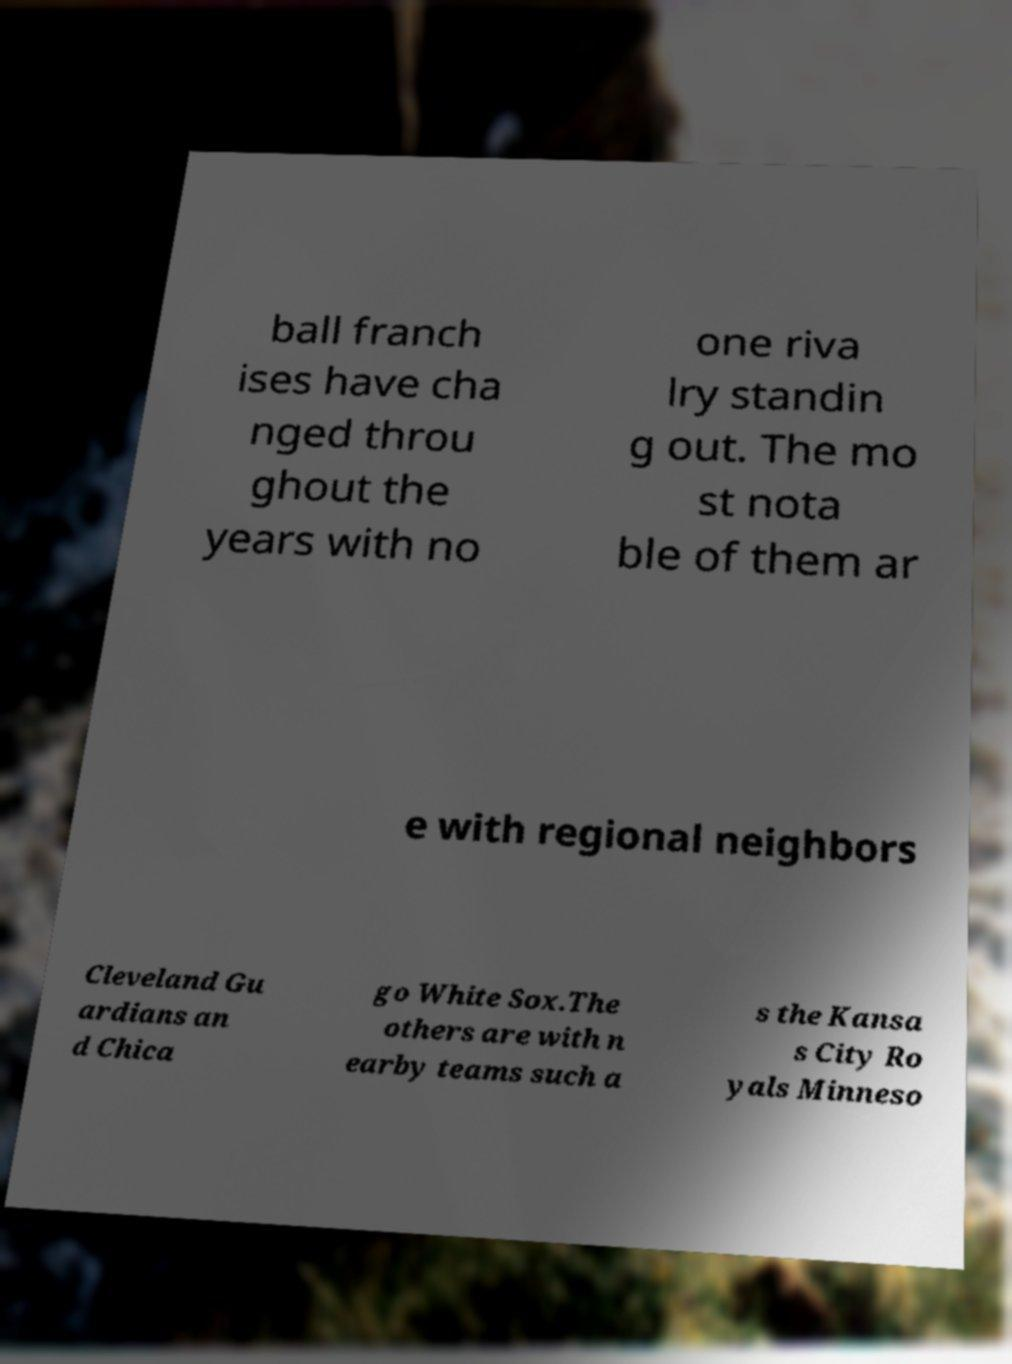There's text embedded in this image that I need extracted. Can you transcribe it verbatim? ball franch ises have cha nged throu ghout the years with no one riva lry standin g out. The mo st nota ble of them ar e with regional neighbors Cleveland Gu ardians an d Chica go White Sox.The others are with n earby teams such a s the Kansa s City Ro yals Minneso 